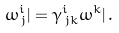Convert formula to latex. <formula><loc_0><loc_0><loc_500><loc_500>\omega ^ { i } _ { \, j } | = \gamma ^ { i } _ { \, j k } \omega ^ { k } | \, .</formula> 